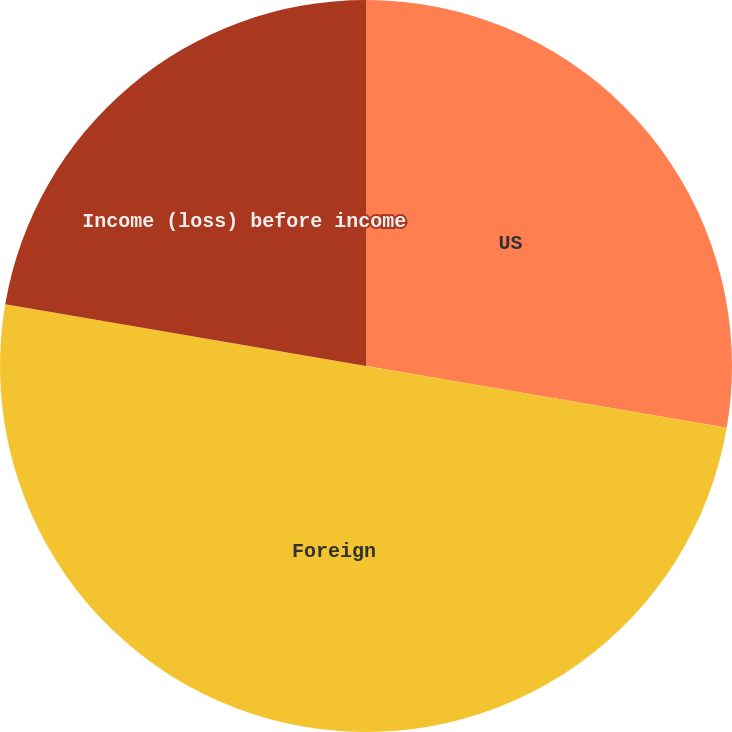Convert chart. <chart><loc_0><loc_0><loc_500><loc_500><pie_chart><fcel>US<fcel>Foreign<fcel>Income (loss) before income<nl><fcel>27.7%<fcel>50.0%<fcel>22.3%<nl></chart> 